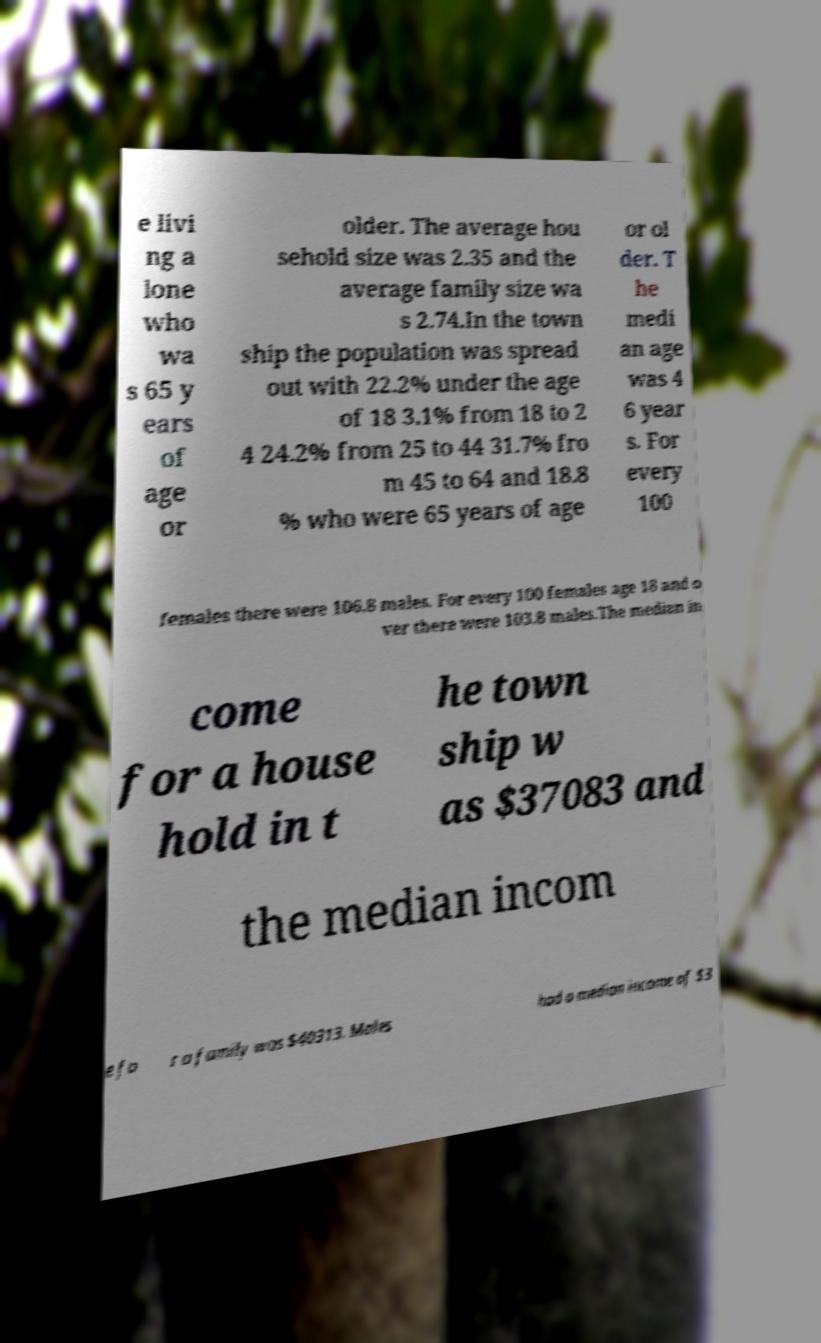There's text embedded in this image that I need extracted. Can you transcribe it verbatim? e livi ng a lone who wa s 65 y ears of age or older. The average hou sehold size was 2.35 and the average family size wa s 2.74.In the town ship the population was spread out with 22.2% under the age of 18 3.1% from 18 to 2 4 24.2% from 25 to 44 31.7% fro m 45 to 64 and 18.8 % who were 65 years of age or ol der. T he medi an age was 4 6 year s. For every 100 females there were 106.8 males. For every 100 females age 18 and o ver there were 103.8 males.The median in come for a house hold in t he town ship w as $37083 and the median incom e fo r a family was $40313. Males had a median income of $3 